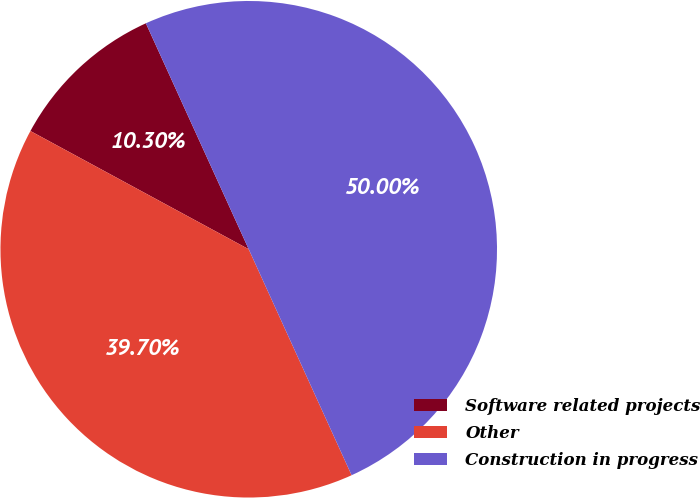Convert chart. <chart><loc_0><loc_0><loc_500><loc_500><pie_chart><fcel>Software related projects<fcel>Other<fcel>Construction in progress<nl><fcel>10.3%<fcel>39.7%<fcel>50.0%<nl></chart> 